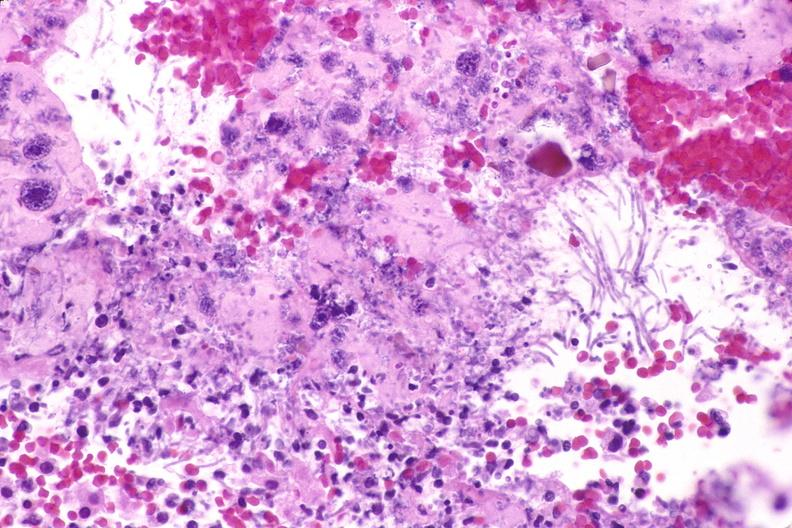s close-up of lesion present?
Answer the question using a single word or phrase. No 